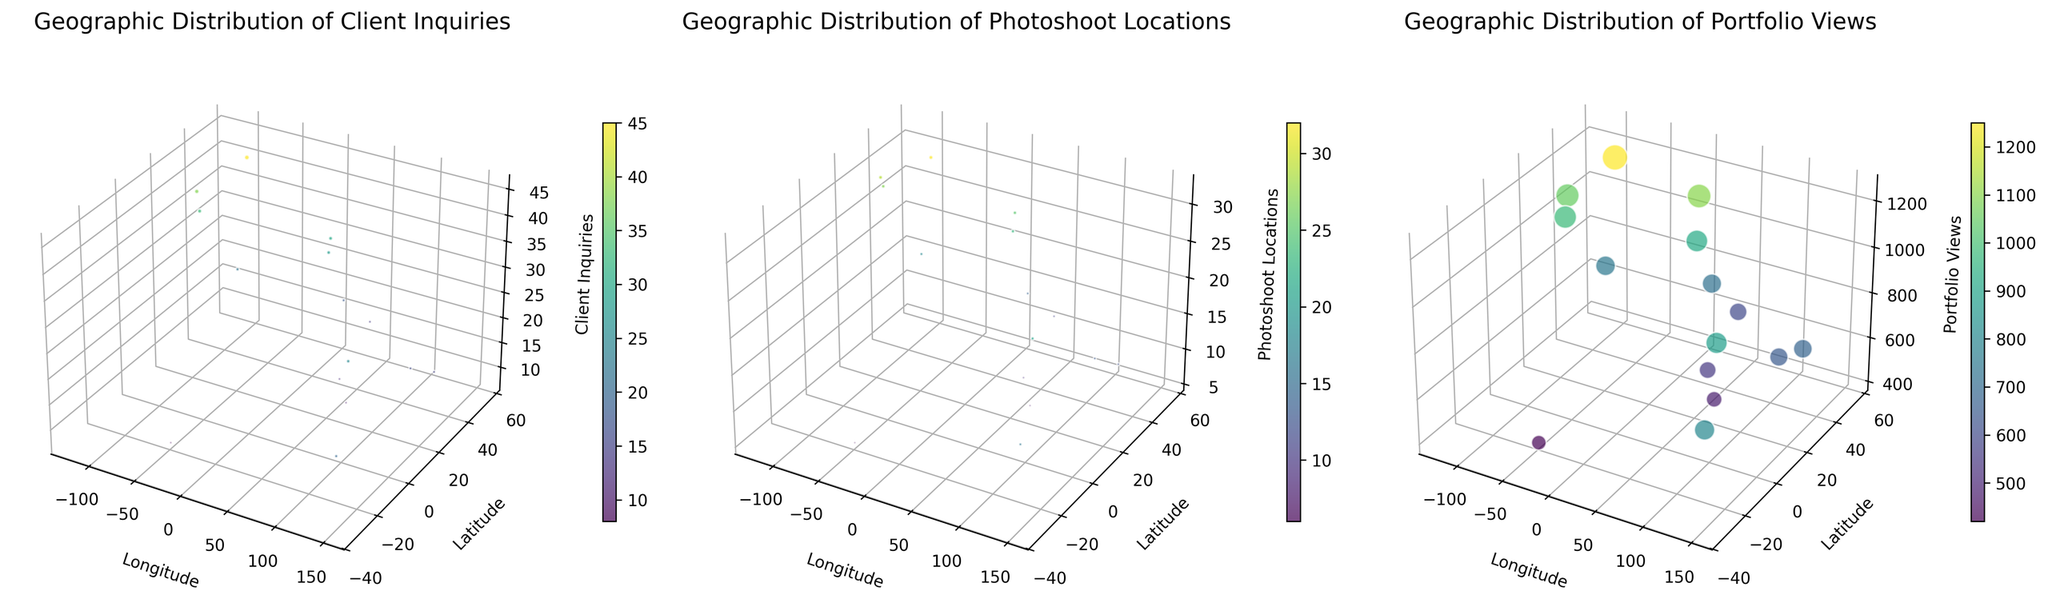What is the title of the plot in the first subplot? The plot's title is found at the top of each subplot, indicating the specific metric displayed. The first subplot includes a title that specifies the metric being represented.
Answer: Geographic Distribution of Client Inquiries How many cities are represented in the subplots? By counting the distinct data points (locations) spread across the subplots, we can discern the total number of cities.
Answer: 15 What color represents the highest values in the subplots? In the color gradient used for the scatter plots, the color representing the highest values can be found by observing which color is used for the largest markers.
Answer: Yellowish-green Which city has the highest number of client inquiries? In the first subplot, comparing all cities based on the value on the Client_Inquiries axis, the city with the highest point can be identified.
Answer: New York City What visual element is used to indicate the size of the values in the subplots? The size of each scatter point varies directly with the size of the values, aiding visual differentiation of data magnitudes.
Answer: Size of scatter points How many client inquiries and photoshoot locations are there combined in Chicago? Locate Chicago in the respective subplots, note the values, and sum them up for a combined metric. In Chicago, Client_Inquiries is 22 and Photoshoot_Locations is 18. Adding these two values together: 22 + 18 = 40.
Answer: 40 Which two cities have the most similar number of photoshoot locations? In the Photoshoot Locations subplot, examine the z-values for each city and find the pair that is closest numerically. London and San Francisco both have 25 and 27 photoshoot locations respectively, the closest pair.
Answer: London and San Francisco How do the number of client inquiries in San Francisco compare to those in Los Angeles? By comparing the number of client inquiries for San Francisco and Los Angeles from the first subplot, we see that San Francisco has slightly more inquiries than Los Angeles. Specifically: San Francisco (33) and Los Angeles (38).
Answer: Los Angeles has more Which city appears to have the least portfolio views? By examining the z-axis representing Portfolio_Views in the third subplot, the smallest value corresponds to the city with the least portfolio views.
Answer: Rio de Janeiro 